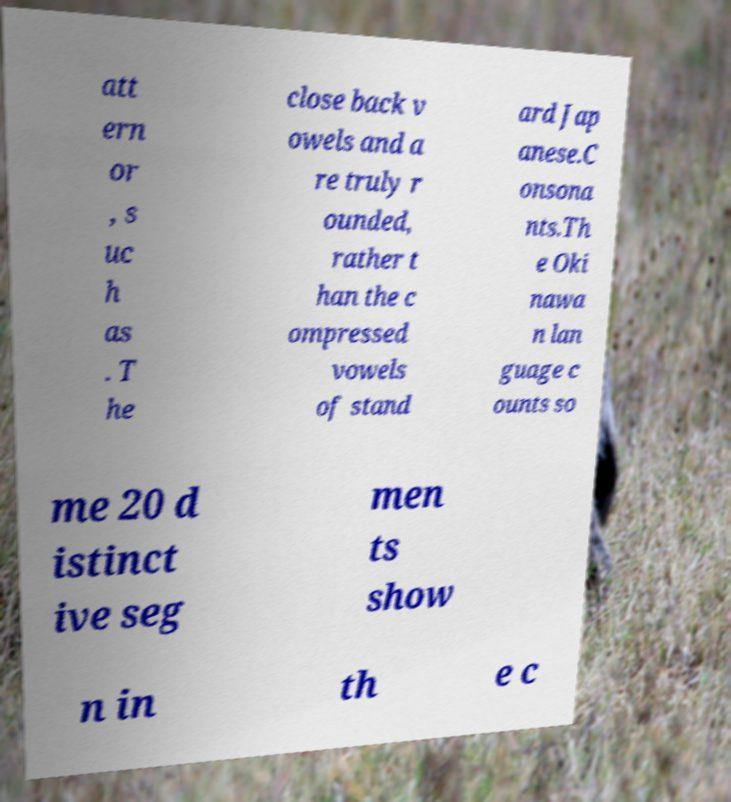There's text embedded in this image that I need extracted. Can you transcribe it verbatim? att ern or , s uc h as . T he close back v owels and a re truly r ounded, rather t han the c ompressed vowels of stand ard Jap anese.C onsona nts.Th e Oki nawa n lan guage c ounts so me 20 d istinct ive seg men ts show n in th e c 